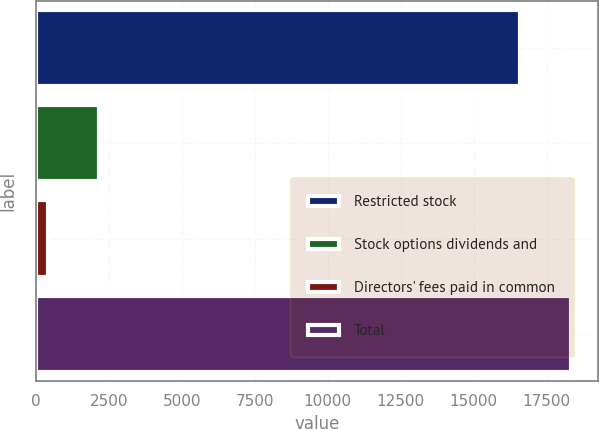Convert chart to OTSL. <chart><loc_0><loc_0><loc_500><loc_500><bar_chart><fcel>Restricted stock<fcel>Stock options dividends and<fcel>Directors' fees paid in common<fcel>Total<nl><fcel>16584<fcel>2160.4<fcel>406<fcel>18338.4<nl></chart> 